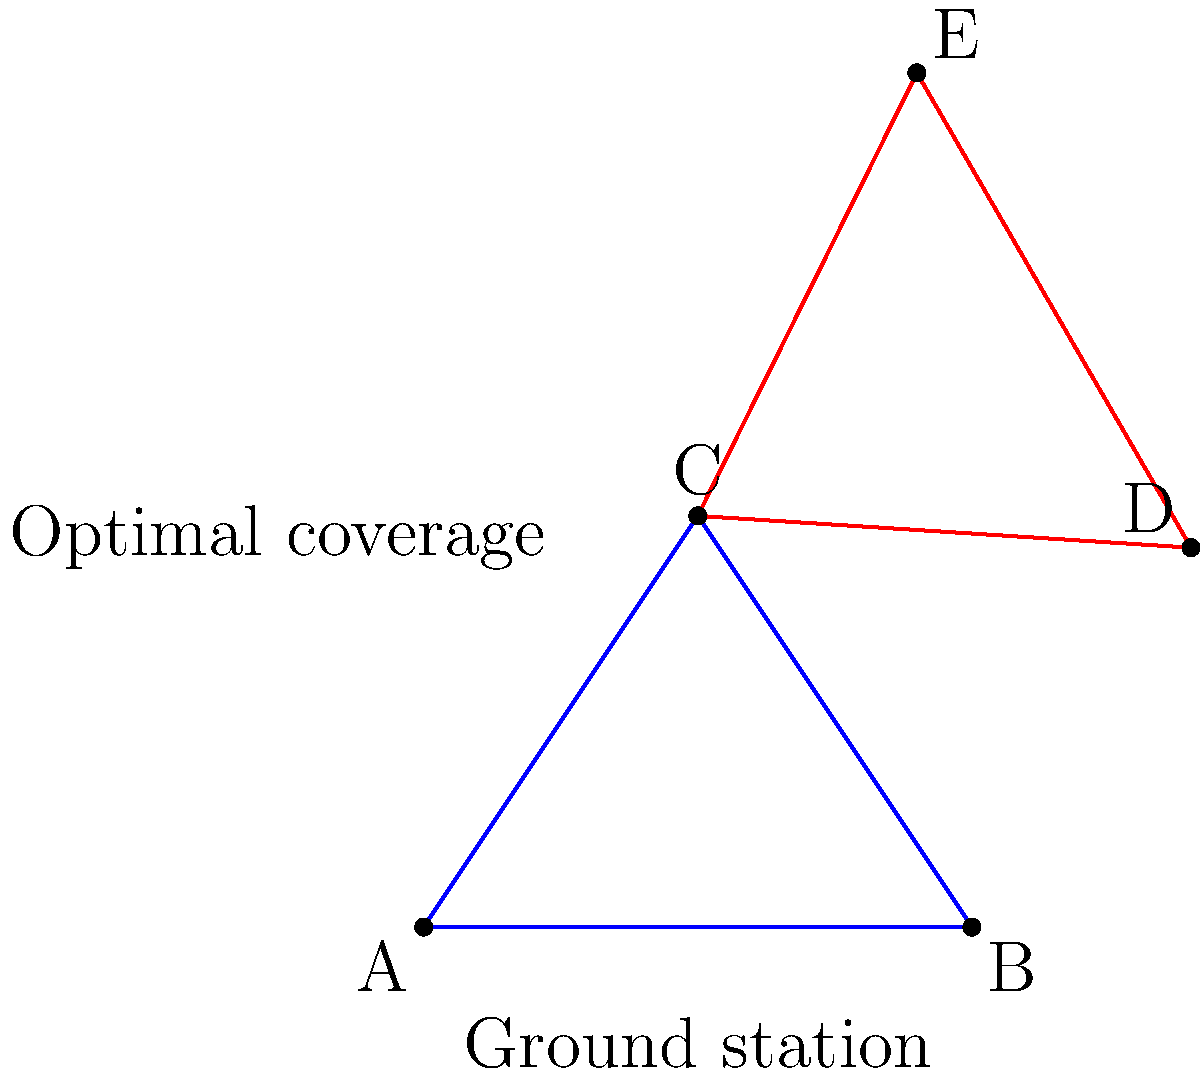In the diagram, triangle ABC represents the current placement of ground stations for a new telescope project. To optimize coverage, the triangle needs to be rotated 120° clockwise around point C. What are the coordinates of point E after the transformation? To solve this problem, we'll follow these steps:

1) First, we need to identify the coordinates of the original points:
   A(0,0), B(4,0), C(2,3)

2) The question asks for the coordinates of point E, which is the transformed position of point B.

3) To rotate a point (x,y) by an angle θ counterclockwise around the origin, we use the rotation matrix:
   $$ \begin{pmatrix} \cos θ & -\sin θ \\ \sin θ & \cos θ \end{pmatrix} $$

4) However, we're rotating 120° clockwise around point C, not the origin. So we need to:
   a) Translate C to the origin
   b) Rotate -120° (equivalent to 240° counterclockwise)
   c) Translate back

5) The rotation matrix for -120° (or 240°) is:
   $$ \begin{pmatrix} -\frac{1}{2} & -\frac{\sqrt{3}}{2} \\ \frac{\sqrt{3}}{2} & -\frac{1}{2} \end{pmatrix} $$

6) The transformation can be expressed as:
   $$ E = C + \begin{pmatrix} -\frac{1}{2} & -\frac{\sqrt{3}}{2} \\ \frac{\sqrt{3}}{2} & -\frac{1}{2} \end{pmatrix} (B - C) $$

7) Calculating:
   $B - C = (4,0) - (2,3) = (2,-3)$
   
   $\begin{pmatrix} -\frac{1}{2} & -\frac{\sqrt{3}}{2} \\ \frac{\sqrt{3}}{2} & -\frac{1}{2} \end{pmatrix} \begin{pmatrix} 2 \\ -3 \end{pmatrix} = \begin{pmatrix} -1-\frac{3\sqrt{3}}{2} \\ \sqrt{3}+\frac{3}{2} \end{pmatrix}$
   
   $E = (2,3) + (-1-\frac{3\sqrt{3}}{2}, \sqrt{3}+\frac{3}{2}) = (1-\frac{3\sqrt{3}}{2}, 3+\sqrt{3}+\frac{3}{2})$

8) Simplifying:
   $E = (1-\frac{3\sqrt{3}}{2}, \frac{9}{2}+\sqrt{3})$
Answer: $(1-\frac{3\sqrt{3}}{2}, \frac{9}{2}+\sqrt{3})$ 